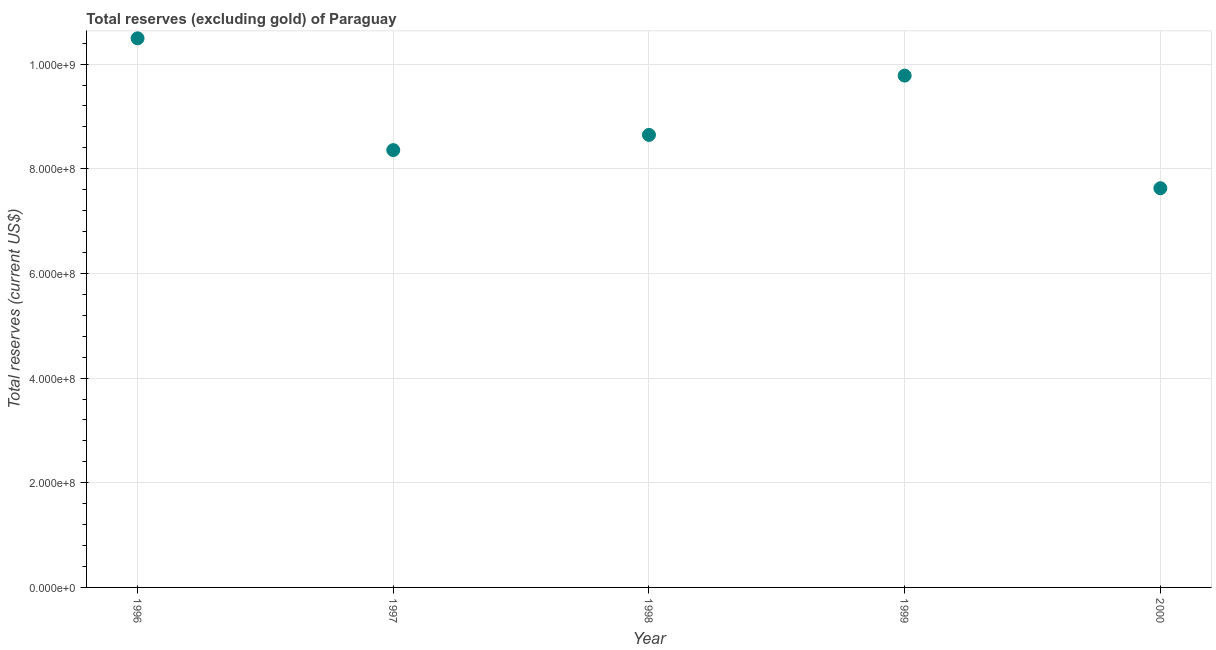What is the total reserves (excluding gold) in 1998?
Your answer should be very brief. 8.65e+08. Across all years, what is the maximum total reserves (excluding gold)?
Your response must be concise. 1.05e+09. Across all years, what is the minimum total reserves (excluding gold)?
Make the answer very short. 7.63e+08. In which year was the total reserves (excluding gold) maximum?
Keep it short and to the point. 1996. In which year was the total reserves (excluding gold) minimum?
Give a very brief answer. 2000. What is the sum of the total reserves (excluding gold)?
Keep it short and to the point. 4.49e+09. What is the difference between the total reserves (excluding gold) in 1996 and 2000?
Ensure brevity in your answer.  2.86e+08. What is the average total reserves (excluding gold) per year?
Your answer should be compact. 8.98e+08. What is the median total reserves (excluding gold)?
Provide a succinct answer. 8.65e+08. Do a majority of the years between 1996 and 1998 (inclusive) have total reserves (excluding gold) greater than 920000000 US$?
Provide a short and direct response. No. What is the ratio of the total reserves (excluding gold) in 1996 to that in 1998?
Provide a short and direct response. 1.21. Is the total reserves (excluding gold) in 1997 less than that in 1999?
Offer a terse response. Yes. What is the difference between the highest and the second highest total reserves (excluding gold)?
Keep it short and to the point. 7.12e+07. What is the difference between the highest and the lowest total reserves (excluding gold)?
Make the answer very short. 2.86e+08. How many dotlines are there?
Ensure brevity in your answer.  1. How many years are there in the graph?
Your response must be concise. 5. Are the values on the major ticks of Y-axis written in scientific E-notation?
Offer a terse response. Yes. Does the graph contain any zero values?
Your answer should be very brief. No. Does the graph contain grids?
Your response must be concise. Yes. What is the title of the graph?
Give a very brief answer. Total reserves (excluding gold) of Paraguay. What is the label or title of the Y-axis?
Your answer should be compact. Total reserves (current US$). What is the Total reserves (current US$) in 1996?
Keep it short and to the point. 1.05e+09. What is the Total reserves (current US$) in 1997?
Give a very brief answer. 8.36e+08. What is the Total reserves (current US$) in 1998?
Make the answer very short. 8.65e+08. What is the Total reserves (current US$) in 1999?
Offer a terse response. 9.78e+08. What is the Total reserves (current US$) in 2000?
Offer a very short reply. 7.63e+08. What is the difference between the Total reserves (current US$) in 1996 and 1997?
Keep it short and to the point. 2.14e+08. What is the difference between the Total reserves (current US$) in 1996 and 1998?
Ensure brevity in your answer.  1.85e+08. What is the difference between the Total reserves (current US$) in 1996 and 1999?
Your answer should be compact. 7.12e+07. What is the difference between the Total reserves (current US$) in 1996 and 2000?
Your response must be concise. 2.86e+08. What is the difference between the Total reserves (current US$) in 1997 and 1998?
Your answer should be compact. -2.91e+07. What is the difference between the Total reserves (current US$) in 1997 and 1999?
Your response must be concise. -1.42e+08. What is the difference between the Total reserves (current US$) in 1997 and 2000?
Provide a short and direct response. 7.28e+07. What is the difference between the Total reserves (current US$) in 1998 and 1999?
Offer a very short reply. -1.13e+08. What is the difference between the Total reserves (current US$) in 1998 and 2000?
Your answer should be very brief. 1.02e+08. What is the difference between the Total reserves (current US$) in 1999 and 2000?
Your answer should be very brief. 2.15e+08. What is the ratio of the Total reserves (current US$) in 1996 to that in 1997?
Offer a very short reply. 1.26. What is the ratio of the Total reserves (current US$) in 1996 to that in 1998?
Provide a succinct answer. 1.21. What is the ratio of the Total reserves (current US$) in 1996 to that in 1999?
Offer a very short reply. 1.07. What is the ratio of the Total reserves (current US$) in 1996 to that in 2000?
Ensure brevity in your answer.  1.38. What is the ratio of the Total reserves (current US$) in 1997 to that in 1998?
Provide a succinct answer. 0.97. What is the ratio of the Total reserves (current US$) in 1997 to that in 1999?
Your response must be concise. 0.85. What is the ratio of the Total reserves (current US$) in 1997 to that in 2000?
Provide a short and direct response. 1.09. What is the ratio of the Total reserves (current US$) in 1998 to that in 1999?
Your response must be concise. 0.88. What is the ratio of the Total reserves (current US$) in 1998 to that in 2000?
Your answer should be compact. 1.13. What is the ratio of the Total reserves (current US$) in 1999 to that in 2000?
Provide a succinct answer. 1.28. 